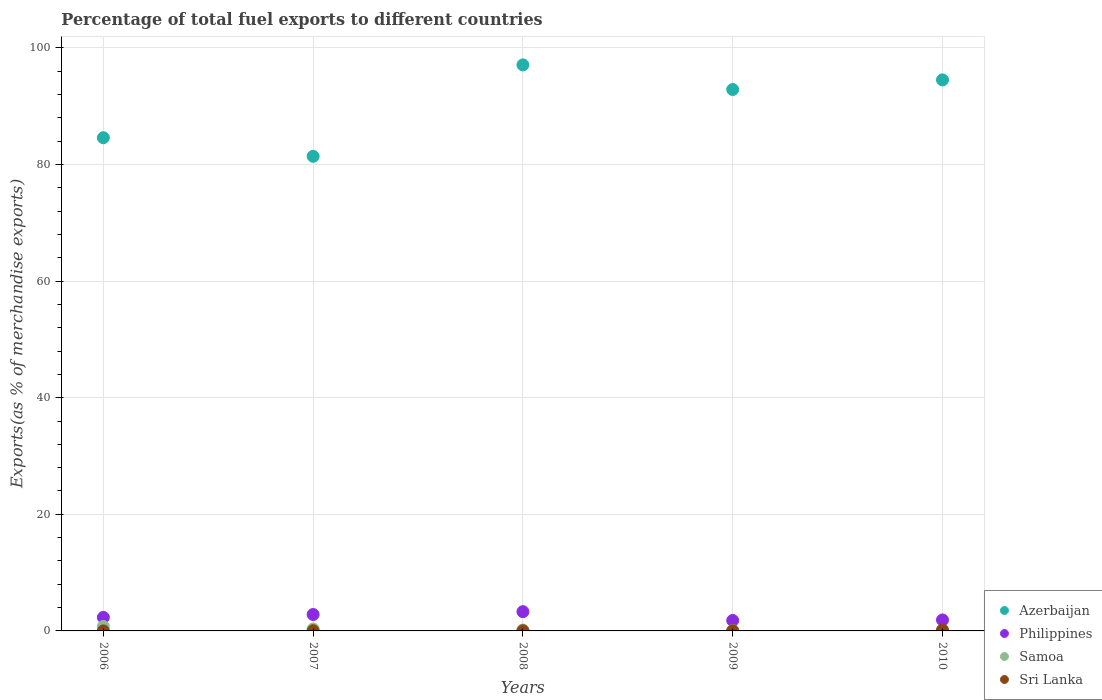How many different coloured dotlines are there?
Keep it short and to the point. 4. What is the percentage of exports to different countries in Sri Lanka in 2008?
Keep it short and to the point. 0.02. Across all years, what is the maximum percentage of exports to different countries in Samoa?
Ensure brevity in your answer.  0.77. Across all years, what is the minimum percentage of exports to different countries in Azerbaijan?
Provide a short and direct response. 81.4. In which year was the percentage of exports to different countries in Samoa minimum?
Make the answer very short. 2010. What is the total percentage of exports to different countries in Sri Lanka in the graph?
Your answer should be very brief. 0.25. What is the difference between the percentage of exports to different countries in Philippines in 2006 and that in 2007?
Give a very brief answer. -0.5. What is the difference between the percentage of exports to different countries in Azerbaijan in 2006 and the percentage of exports to different countries in Sri Lanka in 2008?
Make the answer very short. 84.57. What is the average percentage of exports to different countries in Sri Lanka per year?
Provide a succinct answer. 0.05. In the year 2010, what is the difference between the percentage of exports to different countries in Sri Lanka and percentage of exports to different countries in Azerbaijan?
Your answer should be very brief. -94.35. In how many years, is the percentage of exports to different countries in Azerbaijan greater than 44 %?
Your answer should be compact. 5. What is the ratio of the percentage of exports to different countries in Philippines in 2006 to that in 2007?
Your response must be concise. 0.82. What is the difference between the highest and the second highest percentage of exports to different countries in Philippines?
Give a very brief answer. 0.49. What is the difference between the highest and the lowest percentage of exports to different countries in Samoa?
Offer a terse response. 0.77. Is the sum of the percentage of exports to different countries in Azerbaijan in 2006 and 2008 greater than the maximum percentage of exports to different countries in Samoa across all years?
Your answer should be very brief. Yes. How many years are there in the graph?
Offer a very short reply. 5. What is the difference between two consecutive major ticks on the Y-axis?
Ensure brevity in your answer.  20. Are the values on the major ticks of Y-axis written in scientific E-notation?
Your answer should be compact. No. Does the graph contain any zero values?
Your answer should be compact. No. Does the graph contain grids?
Ensure brevity in your answer.  Yes. Where does the legend appear in the graph?
Your answer should be compact. Bottom right. What is the title of the graph?
Your answer should be very brief. Percentage of total fuel exports to different countries. Does "Sub-Saharan Africa (developing only)" appear as one of the legend labels in the graph?
Ensure brevity in your answer.  No. What is the label or title of the Y-axis?
Ensure brevity in your answer.  Exports(as % of merchandise exports). What is the Exports(as % of merchandise exports) of Azerbaijan in 2006?
Your answer should be very brief. 84.59. What is the Exports(as % of merchandise exports) of Philippines in 2006?
Your response must be concise. 2.32. What is the Exports(as % of merchandise exports) of Samoa in 2006?
Your answer should be very brief. 0.77. What is the Exports(as % of merchandise exports) in Sri Lanka in 2006?
Offer a terse response. 0.01. What is the Exports(as % of merchandise exports) in Azerbaijan in 2007?
Give a very brief answer. 81.4. What is the Exports(as % of merchandise exports) of Philippines in 2007?
Give a very brief answer. 2.82. What is the Exports(as % of merchandise exports) in Samoa in 2007?
Offer a very short reply. 0.33. What is the Exports(as % of merchandise exports) of Sri Lanka in 2007?
Offer a very short reply. 0.03. What is the Exports(as % of merchandise exports) of Azerbaijan in 2008?
Give a very brief answer. 97.08. What is the Exports(as % of merchandise exports) of Philippines in 2008?
Ensure brevity in your answer.  3.3. What is the Exports(as % of merchandise exports) in Samoa in 2008?
Make the answer very short. 0.16. What is the Exports(as % of merchandise exports) in Sri Lanka in 2008?
Offer a very short reply. 0.02. What is the Exports(as % of merchandise exports) of Azerbaijan in 2009?
Your response must be concise. 92.86. What is the Exports(as % of merchandise exports) of Philippines in 2009?
Your answer should be very brief. 1.79. What is the Exports(as % of merchandise exports) in Samoa in 2009?
Your answer should be very brief. 0.07. What is the Exports(as % of merchandise exports) in Sri Lanka in 2009?
Make the answer very short. 0.03. What is the Exports(as % of merchandise exports) of Azerbaijan in 2010?
Make the answer very short. 94.51. What is the Exports(as % of merchandise exports) of Philippines in 2010?
Make the answer very short. 1.88. What is the Exports(as % of merchandise exports) in Samoa in 2010?
Your answer should be very brief. 0. What is the Exports(as % of merchandise exports) in Sri Lanka in 2010?
Your answer should be very brief. 0.16. Across all years, what is the maximum Exports(as % of merchandise exports) in Azerbaijan?
Ensure brevity in your answer.  97.08. Across all years, what is the maximum Exports(as % of merchandise exports) of Philippines?
Your answer should be compact. 3.3. Across all years, what is the maximum Exports(as % of merchandise exports) of Samoa?
Keep it short and to the point. 0.77. Across all years, what is the maximum Exports(as % of merchandise exports) in Sri Lanka?
Ensure brevity in your answer.  0.16. Across all years, what is the minimum Exports(as % of merchandise exports) in Azerbaijan?
Your answer should be very brief. 81.4. Across all years, what is the minimum Exports(as % of merchandise exports) of Philippines?
Keep it short and to the point. 1.79. Across all years, what is the minimum Exports(as % of merchandise exports) of Samoa?
Make the answer very short. 0. Across all years, what is the minimum Exports(as % of merchandise exports) of Sri Lanka?
Your answer should be very brief. 0.01. What is the total Exports(as % of merchandise exports) in Azerbaijan in the graph?
Offer a very short reply. 450.44. What is the total Exports(as % of merchandise exports) in Philippines in the graph?
Provide a short and direct response. 12.12. What is the total Exports(as % of merchandise exports) of Samoa in the graph?
Your answer should be compact. 1.34. What is the total Exports(as % of merchandise exports) of Sri Lanka in the graph?
Your response must be concise. 0.25. What is the difference between the Exports(as % of merchandise exports) in Azerbaijan in 2006 and that in 2007?
Ensure brevity in your answer.  3.19. What is the difference between the Exports(as % of merchandise exports) of Philippines in 2006 and that in 2007?
Your response must be concise. -0.5. What is the difference between the Exports(as % of merchandise exports) in Samoa in 2006 and that in 2007?
Ensure brevity in your answer.  0.44. What is the difference between the Exports(as % of merchandise exports) of Sri Lanka in 2006 and that in 2007?
Offer a terse response. -0.02. What is the difference between the Exports(as % of merchandise exports) of Azerbaijan in 2006 and that in 2008?
Provide a short and direct response. -12.49. What is the difference between the Exports(as % of merchandise exports) of Philippines in 2006 and that in 2008?
Keep it short and to the point. -0.98. What is the difference between the Exports(as % of merchandise exports) of Samoa in 2006 and that in 2008?
Ensure brevity in your answer.  0.61. What is the difference between the Exports(as % of merchandise exports) of Sri Lanka in 2006 and that in 2008?
Your response must be concise. -0.01. What is the difference between the Exports(as % of merchandise exports) in Azerbaijan in 2006 and that in 2009?
Keep it short and to the point. -8.27. What is the difference between the Exports(as % of merchandise exports) in Philippines in 2006 and that in 2009?
Offer a terse response. 0.53. What is the difference between the Exports(as % of merchandise exports) of Samoa in 2006 and that in 2009?
Your response must be concise. 0.7. What is the difference between the Exports(as % of merchandise exports) of Sri Lanka in 2006 and that in 2009?
Offer a very short reply. -0.02. What is the difference between the Exports(as % of merchandise exports) of Azerbaijan in 2006 and that in 2010?
Offer a terse response. -9.92. What is the difference between the Exports(as % of merchandise exports) of Philippines in 2006 and that in 2010?
Provide a short and direct response. 0.44. What is the difference between the Exports(as % of merchandise exports) of Samoa in 2006 and that in 2010?
Ensure brevity in your answer.  0.77. What is the difference between the Exports(as % of merchandise exports) in Sri Lanka in 2006 and that in 2010?
Offer a terse response. -0.15. What is the difference between the Exports(as % of merchandise exports) of Azerbaijan in 2007 and that in 2008?
Keep it short and to the point. -15.68. What is the difference between the Exports(as % of merchandise exports) of Philippines in 2007 and that in 2008?
Give a very brief answer. -0.49. What is the difference between the Exports(as % of merchandise exports) of Samoa in 2007 and that in 2008?
Provide a succinct answer. 0.17. What is the difference between the Exports(as % of merchandise exports) in Sri Lanka in 2007 and that in 2008?
Give a very brief answer. 0.01. What is the difference between the Exports(as % of merchandise exports) of Azerbaijan in 2007 and that in 2009?
Ensure brevity in your answer.  -11.46. What is the difference between the Exports(as % of merchandise exports) of Philippines in 2007 and that in 2009?
Offer a very short reply. 1.02. What is the difference between the Exports(as % of merchandise exports) of Samoa in 2007 and that in 2009?
Your response must be concise. 0.26. What is the difference between the Exports(as % of merchandise exports) of Sri Lanka in 2007 and that in 2009?
Keep it short and to the point. -0. What is the difference between the Exports(as % of merchandise exports) in Azerbaijan in 2007 and that in 2010?
Give a very brief answer. -13.11. What is the difference between the Exports(as % of merchandise exports) in Philippines in 2007 and that in 2010?
Offer a terse response. 0.94. What is the difference between the Exports(as % of merchandise exports) of Samoa in 2007 and that in 2010?
Give a very brief answer. 0.33. What is the difference between the Exports(as % of merchandise exports) of Sri Lanka in 2007 and that in 2010?
Your answer should be compact. -0.13. What is the difference between the Exports(as % of merchandise exports) in Azerbaijan in 2008 and that in 2009?
Provide a short and direct response. 4.23. What is the difference between the Exports(as % of merchandise exports) of Philippines in 2008 and that in 2009?
Make the answer very short. 1.51. What is the difference between the Exports(as % of merchandise exports) in Samoa in 2008 and that in 2009?
Keep it short and to the point. 0.09. What is the difference between the Exports(as % of merchandise exports) of Sri Lanka in 2008 and that in 2009?
Provide a succinct answer. -0.01. What is the difference between the Exports(as % of merchandise exports) in Azerbaijan in 2008 and that in 2010?
Make the answer very short. 2.57. What is the difference between the Exports(as % of merchandise exports) of Philippines in 2008 and that in 2010?
Keep it short and to the point. 1.42. What is the difference between the Exports(as % of merchandise exports) of Samoa in 2008 and that in 2010?
Your answer should be very brief. 0.16. What is the difference between the Exports(as % of merchandise exports) in Sri Lanka in 2008 and that in 2010?
Offer a very short reply. -0.14. What is the difference between the Exports(as % of merchandise exports) in Azerbaijan in 2009 and that in 2010?
Offer a very short reply. -1.65. What is the difference between the Exports(as % of merchandise exports) in Philippines in 2009 and that in 2010?
Your response must be concise. -0.09. What is the difference between the Exports(as % of merchandise exports) in Samoa in 2009 and that in 2010?
Provide a short and direct response. 0.07. What is the difference between the Exports(as % of merchandise exports) in Sri Lanka in 2009 and that in 2010?
Your answer should be very brief. -0.13. What is the difference between the Exports(as % of merchandise exports) of Azerbaijan in 2006 and the Exports(as % of merchandise exports) of Philippines in 2007?
Offer a very short reply. 81.77. What is the difference between the Exports(as % of merchandise exports) of Azerbaijan in 2006 and the Exports(as % of merchandise exports) of Samoa in 2007?
Offer a terse response. 84.26. What is the difference between the Exports(as % of merchandise exports) of Azerbaijan in 2006 and the Exports(as % of merchandise exports) of Sri Lanka in 2007?
Your response must be concise. 84.56. What is the difference between the Exports(as % of merchandise exports) of Philippines in 2006 and the Exports(as % of merchandise exports) of Samoa in 2007?
Your answer should be compact. 1.99. What is the difference between the Exports(as % of merchandise exports) in Philippines in 2006 and the Exports(as % of merchandise exports) in Sri Lanka in 2007?
Offer a terse response. 2.29. What is the difference between the Exports(as % of merchandise exports) in Samoa in 2006 and the Exports(as % of merchandise exports) in Sri Lanka in 2007?
Provide a short and direct response. 0.74. What is the difference between the Exports(as % of merchandise exports) in Azerbaijan in 2006 and the Exports(as % of merchandise exports) in Philippines in 2008?
Provide a short and direct response. 81.29. What is the difference between the Exports(as % of merchandise exports) of Azerbaijan in 2006 and the Exports(as % of merchandise exports) of Samoa in 2008?
Keep it short and to the point. 84.43. What is the difference between the Exports(as % of merchandise exports) of Azerbaijan in 2006 and the Exports(as % of merchandise exports) of Sri Lanka in 2008?
Your answer should be very brief. 84.57. What is the difference between the Exports(as % of merchandise exports) in Philippines in 2006 and the Exports(as % of merchandise exports) in Samoa in 2008?
Give a very brief answer. 2.16. What is the difference between the Exports(as % of merchandise exports) in Philippines in 2006 and the Exports(as % of merchandise exports) in Sri Lanka in 2008?
Make the answer very short. 2.3. What is the difference between the Exports(as % of merchandise exports) of Samoa in 2006 and the Exports(as % of merchandise exports) of Sri Lanka in 2008?
Your answer should be very brief. 0.75. What is the difference between the Exports(as % of merchandise exports) of Azerbaijan in 2006 and the Exports(as % of merchandise exports) of Philippines in 2009?
Provide a short and direct response. 82.8. What is the difference between the Exports(as % of merchandise exports) of Azerbaijan in 2006 and the Exports(as % of merchandise exports) of Samoa in 2009?
Offer a very short reply. 84.52. What is the difference between the Exports(as % of merchandise exports) in Azerbaijan in 2006 and the Exports(as % of merchandise exports) in Sri Lanka in 2009?
Make the answer very short. 84.56. What is the difference between the Exports(as % of merchandise exports) in Philippines in 2006 and the Exports(as % of merchandise exports) in Samoa in 2009?
Ensure brevity in your answer.  2.25. What is the difference between the Exports(as % of merchandise exports) in Philippines in 2006 and the Exports(as % of merchandise exports) in Sri Lanka in 2009?
Your answer should be compact. 2.29. What is the difference between the Exports(as % of merchandise exports) in Samoa in 2006 and the Exports(as % of merchandise exports) in Sri Lanka in 2009?
Offer a very short reply. 0.74. What is the difference between the Exports(as % of merchandise exports) in Azerbaijan in 2006 and the Exports(as % of merchandise exports) in Philippines in 2010?
Give a very brief answer. 82.71. What is the difference between the Exports(as % of merchandise exports) of Azerbaijan in 2006 and the Exports(as % of merchandise exports) of Samoa in 2010?
Keep it short and to the point. 84.59. What is the difference between the Exports(as % of merchandise exports) in Azerbaijan in 2006 and the Exports(as % of merchandise exports) in Sri Lanka in 2010?
Make the answer very short. 84.43. What is the difference between the Exports(as % of merchandise exports) of Philippines in 2006 and the Exports(as % of merchandise exports) of Samoa in 2010?
Give a very brief answer. 2.32. What is the difference between the Exports(as % of merchandise exports) of Philippines in 2006 and the Exports(as % of merchandise exports) of Sri Lanka in 2010?
Keep it short and to the point. 2.16. What is the difference between the Exports(as % of merchandise exports) of Samoa in 2006 and the Exports(as % of merchandise exports) of Sri Lanka in 2010?
Make the answer very short. 0.61. What is the difference between the Exports(as % of merchandise exports) of Azerbaijan in 2007 and the Exports(as % of merchandise exports) of Philippines in 2008?
Provide a succinct answer. 78.09. What is the difference between the Exports(as % of merchandise exports) of Azerbaijan in 2007 and the Exports(as % of merchandise exports) of Samoa in 2008?
Keep it short and to the point. 81.24. What is the difference between the Exports(as % of merchandise exports) of Azerbaijan in 2007 and the Exports(as % of merchandise exports) of Sri Lanka in 2008?
Give a very brief answer. 81.38. What is the difference between the Exports(as % of merchandise exports) of Philippines in 2007 and the Exports(as % of merchandise exports) of Samoa in 2008?
Give a very brief answer. 2.66. What is the difference between the Exports(as % of merchandise exports) in Philippines in 2007 and the Exports(as % of merchandise exports) in Sri Lanka in 2008?
Give a very brief answer. 2.79. What is the difference between the Exports(as % of merchandise exports) in Samoa in 2007 and the Exports(as % of merchandise exports) in Sri Lanka in 2008?
Provide a short and direct response. 0.31. What is the difference between the Exports(as % of merchandise exports) in Azerbaijan in 2007 and the Exports(as % of merchandise exports) in Philippines in 2009?
Your answer should be very brief. 79.61. What is the difference between the Exports(as % of merchandise exports) in Azerbaijan in 2007 and the Exports(as % of merchandise exports) in Samoa in 2009?
Provide a short and direct response. 81.33. What is the difference between the Exports(as % of merchandise exports) of Azerbaijan in 2007 and the Exports(as % of merchandise exports) of Sri Lanka in 2009?
Ensure brevity in your answer.  81.37. What is the difference between the Exports(as % of merchandise exports) of Philippines in 2007 and the Exports(as % of merchandise exports) of Samoa in 2009?
Ensure brevity in your answer.  2.75. What is the difference between the Exports(as % of merchandise exports) of Philippines in 2007 and the Exports(as % of merchandise exports) of Sri Lanka in 2009?
Offer a terse response. 2.79. What is the difference between the Exports(as % of merchandise exports) of Samoa in 2007 and the Exports(as % of merchandise exports) of Sri Lanka in 2009?
Your answer should be very brief. 0.3. What is the difference between the Exports(as % of merchandise exports) in Azerbaijan in 2007 and the Exports(as % of merchandise exports) in Philippines in 2010?
Ensure brevity in your answer.  79.52. What is the difference between the Exports(as % of merchandise exports) in Azerbaijan in 2007 and the Exports(as % of merchandise exports) in Samoa in 2010?
Offer a very short reply. 81.4. What is the difference between the Exports(as % of merchandise exports) in Azerbaijan in 2007 and the Exports(as % of merchandise exports) in Sri Lanka in 2010?
Give a very brief answer. 81.24. What is the difference between the Exports(as % of merchandise exports) in Philippines in 2007 and the Exports(as % of merchandise exports) in Samoa in 2010?
Your answer should be compact. 2.81. What is the difference between the Exports(as % of merchandise exports) in Philippines in 2007 and the Exports(as % of merchandise exports) in Sri Lanka in 2010?
Offer a very short reply. 2.66. What is the difference between the Exports(as % of merchandise exports) in Samoa in 2007 and the Exports(as % of merchandise exports) in Sri Lanka in 2010?
Keep it short and to the point. 0.17. What is the difference between the Exports(as % of merchandise exports) in Azerbaijan in 2008 and the Exports(as % of merchandise exports) in Philippines in 2009?
Ensure brevity in your answer.  95.29. What is the difference between the Exports(as % of merchandise exports) of Azerbaijan in 2008 and the Exports(as % of merchandise exports) of Samoa in 2009?
Provide a succinct answer. 97.01. What is the difference between the Exports(as % of merchandise exports) of Azerbaijan in 2008 and the Exports(as % of merchandise exports) of Sri Lanka in 2009?
Offer a terse response. 97.05. What is the difference between the Exports(as % of merchandise exports) in Philippines in 2008 and the Exports(as % of merchandise exports) in Samoa in 2009?
Offer a terse response. 3.23. What is the difference between the Exports(as % of merchandise exports) of Philippines in 2008 and the Exports(as % of merchandise exports) of Sri Lanka in 2009?
Offer a very short reply. 3.27. What is the difference between the Exports(as % of merchandise exports) in Samoa in 2008 and the Exports(as % of merchandise exports) in Sri Lanka in 2009?
Offer a terse response. 0.13. What is the difference between the Exports(as % of merchandise exports) of Azerbaijan in 2008 and the Exports(as % of merchandise exports) of Philippines in 2010?
Ensure brevity in your answer.  95.2. What is the difference between the Exports(as % of merchandise exports) in Azerbaijan in 2008 and the Exports(as % of merchandise exports) in Samoa in 2010?
Provide a short and direct response. 97.08. What is the difference between the Exports(as % of merchandise exports) in Azerbaijan in 2008 and the Exports(as % of merchandise exports) in Sri Lanka in 2010?
Make the answer very short. 96.92. What is the difference between the Exports(as % of merchandise exports) of Philippines in 2008 and the Exports(as % of merchandise exports) of Samoa in 2010?
Provide a succinct answer. 3.3. What is the difference between the Exports(as % of merchandise exports) in Philippines in 2008 and the Exports(as % of merchandise exports) in Sri Lanka in 2010?
Offer a terse response. 3.15. What is the difference between the Exports(as % of merchandise exports) of Samoa in 2008 and the Exports(as % of merchandise exports) of Sri Lanka in 2010?
Your answer should be compact. 0. What is the difference between the Exports(as % of merchandise exports) in Azerbaijan in 2009 and the Exports(as % of merchandise exports) in Philippines in 2010?
Make the answer very short. 90.97. What is the difference between the Exports(as % of merchandise exports) of Azerbaijan in 2009 and the Exports(as % of merchandise exports) of Samoa in 2010?
Make the answer very short. 92.85. What is the difference between the Exports(as % of merchandise exports) of Azerbaijan in 2009 and the Exports(as % of merchandise exports) of Sri Lanka in 2010?
Keep it short and to the point. 92.7. What is the difference between the Exports(as % of merchandise exports) in Philippines in 2009 and the Exports(as % of merchandise exports) in Samoa in 2010?
Your answer should be compact. 1.79. What is the difference between the Exports(as % of merchandise exports) of Philippines in 2009 and the Exports(as % of merchandise exports) of Sri Lanka in 2010?
Keep it short and to the point. 1.63. What is the difference between the Exports(as % of merchandise exports) of Samoa in 2009 and the Exports(as % of merchandise exports) of Sri Lanka in 2010?
Keep it short and to the point. -0.09. What is the average Exports(as % of merchandise exports) in Azerbaijan per year?
Your response must be concise. 90.09. What is the average Exports(as % of merchandise exports) in Philippines per year?
Ensure brevity in your answer.  2.42. What is the average Exports(as % of merchandise exports) of Samoa per year?
Offer a very short reply. 0.27. What is the average Exports(as % of merchandise exports) in Sri Lanka per year?
Provide a short and direct response. 0.05. In the year 2006, what is the difference between the Exports(as % of merchandise exports) in Azerbaijan and Exports(as % of merchandise exports) in Philippines?
Your answer should be very brief. 82.27. In the year 2006, what is the difference between the Exports(as % of merchandise exports) in Azerbaijan and Exports(as % of merchandise exports) in Samoa?
Ensure brevity in your answer.  83.82. In the year 2006, what is the difference between the Exports(as % of merchandise exports) of Azerbaijan and Exports(as % of merchandise exports) of Sri Lanka?
Keep it short and to the point. 84.58. In the year 2006, what is the difference between the Exports(as % of merchandise exports) of Philippines and Exports(as % of merchandise exports) of Samoa?
Your answer should be compact. 1.55. In the year 2006, what is the difference between the Exports(as % of merchandise exports) of Philippines and Exports(as % of merchandise exports) of Sri Lanka?
Give a very brief answer. 2.31. In the year 2006, what is the difference between the Exports(as % of merchandise exports) in Samoa and Exports(as % of merchandise exports) in Sri Lanka?
Your answer should be compact. 0.76. In the year 2007, what is the difference between the Exports(as % of merchandise exports) in Azerbaijan and Exports(as % of merchandise exports) in Philippines?
Offer a terse response. 78.58. In the year 2007, what is the difference between the Exports(as % of merchandise exports) in Azerbaijan and Exports(as % of merchandise exports) in Samoa?
Keep it short and to the point. 81.07. In the year 2007, what is the difference between the Exports(as % of merchandise exports) in Azerbaijan and Exports(as % of merchandise exports) in Sri Lanka?
Keep it short and to the point. 81.37. In the year 2007, what is the difference between the Exports(as % of merchandise exports) in Philippines and Exports(as % of merchandise exports) in Samoa?
Give a very brief answer. 2.48. In the year 2007, what is the difference between the Exports(as % of merchandise exports) in Philippines and Exports(as % of merchandise exports) in Sri Lanka?
Offer a terse response. 2.79. In the year 2007, what is the difference between the Exports(as % of merchandise exports) of Samoa and Exports(as % of merchandise exports) of Sri Lanka?
Offer a very short reply. 0.3. In the year 2008, what is the difference between the Exports(as % of merchandise exports) of Azerbaijan and Exports(as % of merchandise exports) of Philippines?
Give a very brief answer. 93.78. In the year 2008, what is the difference between the Exports(as % of merchandise exports) of Azerbaijan and Exports(as % of merchandise exports) of Samoa?
Offer a terse response. 96.92. In the year 2008, what is the difference between the Exports(as % of merchandise exports) in Azerbaijan and Exports(as % of merchandise exports) in Sri Lanka?
Ensure brevity in your answer.  97.06. In the year 2008, what is the difference between the Exports(as % of merchandise exports) in Philippines and Exports(as % of merchandise exports) in Samoa?
Provide a short and direct response. 3.15. In the year 2008, what is the difference between the Exports(as % of merchandise exports) of Philippines and Exports(as % of merchandise exports) of Sri Lanka?
Offer a very short reply. 3.28. In the year 2008, what is the difference between the Exports(as % of merchandise exports) of Samoa and Exports(as % of merchandise exports) of Sri Lanka?
Provide a succinct answer. 0.14. In the year 2009, what is the difference between the Exports(as % of merchandise exports) in Azerbaijan and Exports(as % of merchandise exports) in Philippines?
Your answer should be very brief. 91.06. In the year 2009, what is the difference between the Exports(as % of merchandise exports) in Azerbaijan and Exports(as % of merchandise exports) in Samoa?
Ensure brevity in your answer.  92.79. In the year 2009, what is the difference between the Exports(as % of merchandise exports) of Azerbaijan and Exports(as % of merchandise exports) of Sri Lanka?
Give a very brief answer. 92.83. In the year 2009, what is the difference between the Exports(as % of merchandise exports) of Philippines and Exports(as % of merchandise exports) of Samoa?
Provide a succinct answer. 1.72. In the year 2009, what is the difference between the Exports(as % of merchandise exports) of Philippines and Exports(as % of merchandise exports) of Sri Lanka?
Keep it short and to the point. 1.76. In the year 2009, what is the difference between the Exports(as % of merchandise exports) in Samoa and Exports(as % of merchandise exports) in Sri Lanka?
Keep it short and to the point. 0.04. In the year 2010, what is the difference between the Exports(as % of merchandise exports) in Azerbaijan and Exports(as % of merchandise exports) in Philippines?
Your answer should be very brief. 92.63. In the year 2010, what is the difference between the Exports(as % of merchandise exports) in Azerbaijan and Exports(as % of merchandise exports) in Samoa?
Provide a succinct answer. 94.51. In the year 2010, what is the difference between the Exports(as % of merchandise exports) of Azerbaijan and Exports(as % of merchandise exports) of Sri Lanka?
Offer a very short reply. 94.35. In the year 2010, what is the difference between the Exports(as % of merchandise exports) of Philippines and Exports(as % of merchandise exports) of Samoa?
Keep it short and to the point. 1.88. In the year 2010, what is the difference between the Exports(as % of merchandise exports) in Philippines and Exports(as % of merchandise exports) in Sri Lanka?
Your response must be concise. 1.72. In the year 2010, what is the difference between the Exports(as % of merchandise exports) of Samoa and Exports(as % of merchandise exports) of Sri Lanka?
Offer a terse response. -0.16. What is the ratio of the Exports(as % of merchandise exports) in Azerbaijan in 2006 to that in 2007?
Your answer should be very brief. 1.04. What is the ratio of the Exports(as % of merchandise exports) in Philippines in 2006 to that in 2007?
Your answer should be compact. 0.82. What is the ratio of the Exports(as % of merchandise exports) in Samoa in 2006 to that in 2007?
Make the answer very short. 2.32. What is the ratio of the Exports(as % of merchandise exports) in Sri Lanka in 2006 to that in 2007?
Keep it short and to the point. 0.35. What is the ratio of the Exports(as % of merchandise exports) in Azerbaijan in 2006 to that in 2008?
Provide a short and direct response. 0.87. What is the ratio of the Exports(as % of merchandise exports) in Philippines in 2006 to that in 2008?
Keep it short and to the point. 0.7. What is the ratio of the Exports(as % of merchandise exports) in Samoa in 2006 to that in 2008?
Provide a short and direct response. 4.83. What is the ratio of the Exports(as % of merchandise exports) in Sri Lanka in 2006 to that in 2008?
Provide a succinct answer. 0.47. What is the ratio of the Exports(as % of merchandise exports) in Azerbaijan in 2006 to that in 2009?
Give a very brief answer. 0.91. What is the ratio of the Exports(as % of merchandise exports) in Philippines in 2006 to that in 2009?
Ensure brevity in your answer.  1.29. What is the ratio of the Exports(as % of merchandise exports) in Samoa in 2006 to that in 2009?
Make the answer very short. 10.88. What is the ratio of the Exports(as % of merchandise exports) in Sri Lanka in 2006 to that in 2009?
Provide a succinct answer. 0.35. What is the ratio of the Exports(as % of merchandise exports) of Azerbaijan in 2006 to that in 2010?
Ensure brevity in your answer.  0.9. What is the ratio of the Exports(as % of merchandise exports) in Philippines in 2006 to that in 2010?
Offer a terse response. 1.23. What is the ratio of the Exports(as % of merchandise exports) in Samoa in 2006 to that in 2010?
Make the answer very short. 249.51. What is the ratio of the Exports(as % of merchandise exports) of Sri Lanka in 2006 to that in 2010?
Your answer should be compact. 0.07. What is the ratio of the Exports(as % of merchandise exports) of Azerbaijan in 2007 to that in 2008?
Keep it short and to the point. 0.84. What is the ratio of the Exports(as % of merchandise exports) in Philippines in 2007 to that in 2008?
Offer a very short reply. 0.85. What is the ratio of the Exports(as % of merchandise exports) in Samoa in 2007 to that in 2008?
Your answer should be very brief. 2.08. What is the ratio of the Exports(as % of merchandise exports) of Sri Lanka in 2007 to that in 2008?
Your answer should be very brief. 1.32. What is the ratio of the Exports(as % of merchandise exports) in Azerbaijan in 2007 to that in 2009?
Make the answer very short. 0.88. What is the ratio of the Exports(as % of merchandise exports) of Philippines in 2007 to that in 2009?
Provide a short and direct response. 1.57. What is the ratio of the Exports(as % of merchandise exports) in Samoa in 2007 to that in 2009?
Your answer should be compact. 4.69. What is the ratio of the Exports(as % of merchandise exports) of Sri Lanka in 2007 to that in 2009?
Offer a very short reply. 0.98. What is the ratio of the Exports(as % of merchandise exports) of Azerbaijan in 2007 to that in 2010?
Provide a short and direct response. 0.86. What is the ratio of the Exports(as % of merchandise exports) of Philippines in 2007 to that in 2010?
Give a very brief answer. 1.5. What is the ratio of the Exports(as % of merchandise exports) in Samoa in 2007 to that in 2010?
Keep it short and to the point. 107.62. What is the ratio of the Exports(as % of merchandise exports) in Sri Lanka in 2007 to that in 2010?
Ensure brevity in your answer.  0.19. What is the ratio of the Exports(as % of merchandise exports) of Azerbaijan in 2008 to that in 2009?
Ensure brevity in your answer.  1.05. What is the ratio of the Exports(as % of merchandise exports) of Philippines in 2008 to that in 2009?
Offer a terse response. 1.84. What is the ratio of the Exports(as % of merchandise exports) in Samoa in 2008 to that in 2009?
Offer a very short reply. 2.25. What is the ratio of the Exports(as % of merchandise exports) in Sri Lanka in 2008 to that in 2009?
Give a very brief answer. 0.74. What is the ratio of the Exports(as % of merchandise exports) in Azerbaijan in 2008 to that in 2010?
Provide a short and direct response. 1.03. What is the ratio of the Exports(as % of merchandise exports) in Philippines in 2008 to that in 2010?
Offer a very short reply. 1.76. What is the ratio of the Exports(as % of merchandise exports) in Samoa in 2008 to that in 2010?
Keep it short and to the point. 51.66. What is the ratio of the Exports(as % of merchandise exports) in Sri Lanka in 2008 to that in 2010?
Offer a very short reply. 0.15. What is the ratio of the Exports(as % of merchandise exports) in Azerbaijan in 2009 to that in 2010?
Provide a short and direct response. 0.98. What is the ratio of the Exports(as % of merchandise exports) in Philippines in 2009 to that in 2010?
Keep it short and to the point. 0.95. What is the ratio of the Exports(as % of merchandise exports) of Samoa in 2009 to that in 2010?
Ensure brevity in your answer.  22.94. What is the ratio of the Exports(as % of merchandise exports) of Sri Lanka in 2009 to that in 2010?
Keep it short and to the point. 0.2. What is the difference between the highest and the second highest Exports(as % of merchandise exports) in Azerbaijan?
Give a very brief answer. 2.57. What is the difference between the highest and the second highest Exports(as % of merchandise exports) of Philippines?
Your answer should be compact. 0.49. What is the difference between the highest and the second highest Exports(as % of merchandise exports) of Samoa?
Offer a terse response. 0.44. What is the difference between the highest and the second highest Exports(as % of merchandise exports) of Sri Lanka?
Offer a terse response. 0.13. What is the difference between the highest and the lowest Exports(as % of merchandise exports) in Azerbaijan?
Offer a terse response. 15.68. What is the difference between the highest and the lowest Exports(as % of merchandise exports) in Philippines?
Your response must be concise. 1.51. What is the difference between the highest and the lowest Exports(as % of merchandise exports) in Samoa?
Your answer should be very brief. 0.77. What is the difference between the highest and the lowest Exports(as % of merchandise exports) of Sri Lanka?
Ensure brevity in your answer.  0.15. 